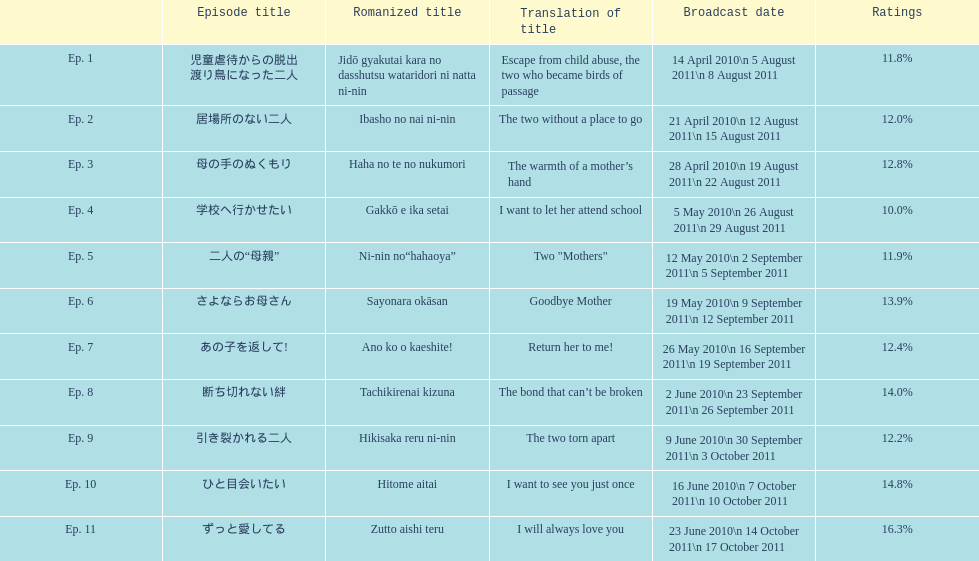What is the title of the show's debut episode? 児童虐待からの脱出 渡り鳥になった二人. 